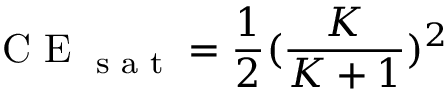Convert formula to latex. <formula><loc_0><loc_0><loc_500><loc_500>C E _ { s a t } = \frac { 1 } { 2 } ( \frac { K } { K + 1 } ) ^ { 2 }</formula> 